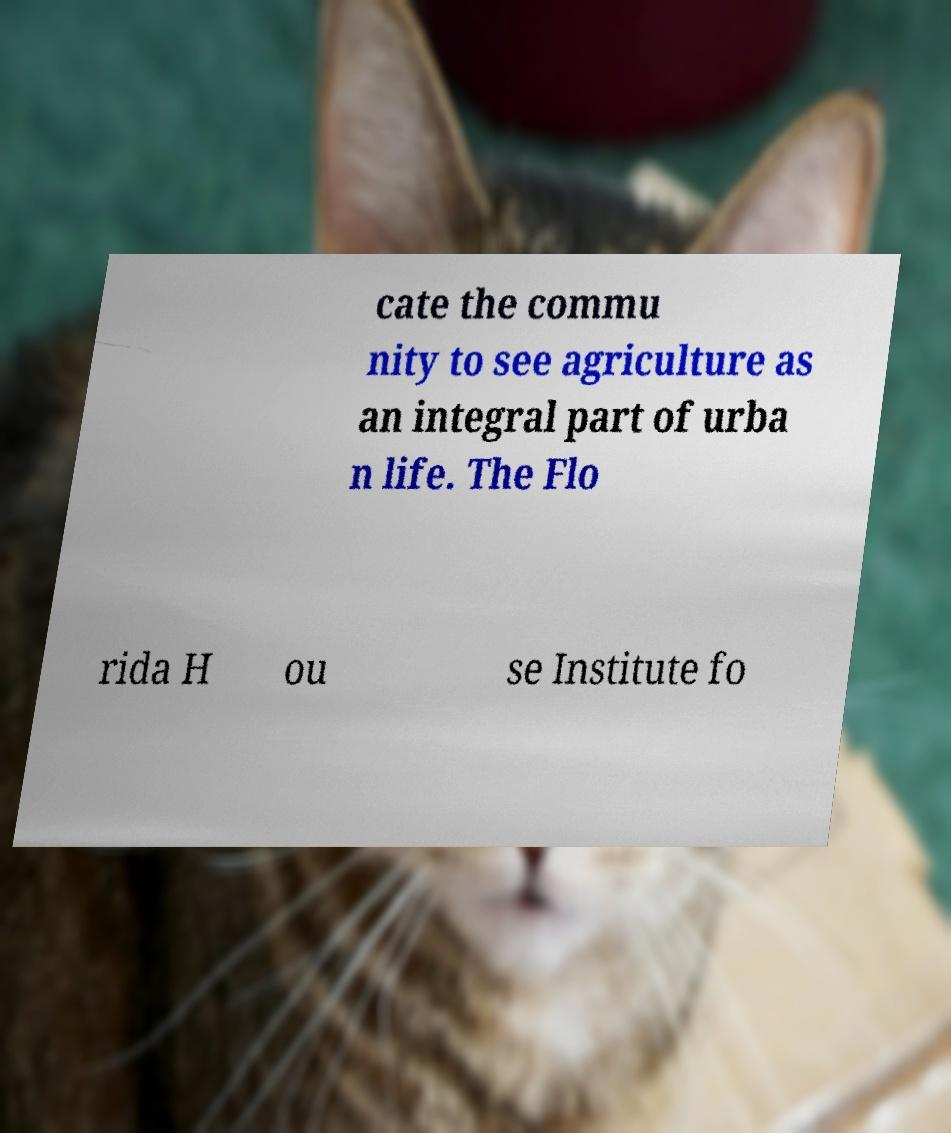I need the written content from this picture converted into text. Can you do that? cate the commu nity to see agriculture as an integral part of urba n life. The Flo rida H ou se Institute fo 